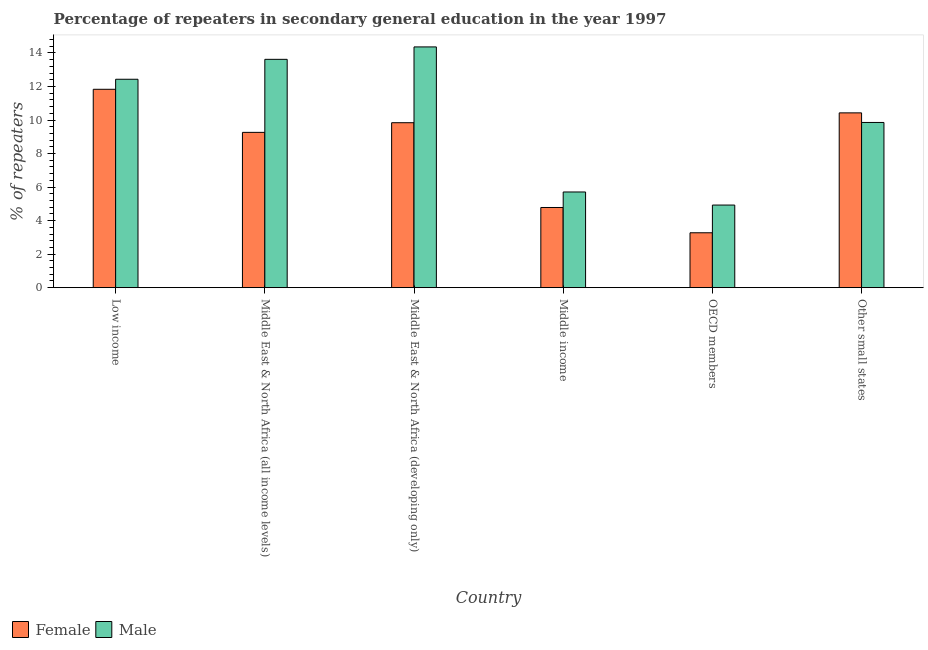How many different coloured bars are there?
Offer a terse response. 2. How many groups of bars are there?
Keep it short and to the point. 6. Are the number of bars on each tick of the X-axis equal?
Ensure brevity in your answer.  Yes. In how many cases, is the number of bars for a given country not equal to the number of legend labels?
Offer a very short reply. 0. What is the percentage of female repeaters in OECD members?
Make the answer very short. 3.27. Across all countries, what is the maximum percentage of female repeaters?
Give a very brief answer. 11.83. Across all countries, what is the minimum percentage of male repeaters?
Give a very brief answer. 4.93. In which country was the percentage of female repeaters maximum?
Offer a very short reply. Low income. In which country was the percentage of male repeaters minimum?
Ensure brevity in your answer.  OECD members. What is the total percentage of male repeaters in the graph?
Keep it short and to the point. 60.9. What is the difference between the percentage of female repeaters in Low income and that in Middle East & North Africa (developing only)?
Your answer should be very brief. 1.99. What is the difference between the percentage of female repeaters in OECD members and the percentage of male repeaters in Middle East & North Africa (all income levels)?
Give a very brief answer. -10.35. What is the average percentage of male repeaters per country?
Your answer should be very brief. 10.15. What is the difference between the percentage of female repeaters and percentage of male repeaters in Middle East & North Africa (all income levels)?
Ensure brevity in your answer.  -4.36. What is the ratio of the percentage of female repeaters in Middle East & North Africa (all income levels) to that in Middle East & North Africa (developing only)?
Offer a very short reply. 0.94. What is the difference between the highest and the second highest percentage of female repeaters?
Your answer should be compact. 1.41. What is the difference between the highest and the lowest percentage of male repeaters?
Your response must be concise. 9.43. Is the sum of the percentage of male repeaters in Middle East & North Africa (developing only) and OECD members greater than the maximum percentage of female repeaters across all countries?
Your response must be concise. Yes. What does the 1st bar from the right in Other small states represents?
Your response must be concise. Male. How many bars are there?
Your response must be concise. 12. Are all the bars in the graph horizontal?
Make the answer very short. No. How many countries are there in the graph?
Offer a terse response. 6. What is the difference between two consecutive major ticks on the Y-axis?
Give a very brief answer. 2. Does the graph contain grids?
Provide a succinct answer. No. How many legend labels are there?
Provide a succinct answer. 2. What is the title of the graph?
Keep it short and to the point. Percentage of repeaters in secondary general education in the year 1997. Does "Subsidies" appear as one of the legend labels in the graph?
Your answer should be very brief. No. What is the label or title of the Y-axis?
Provide a succinct answer. % of repeaters. What is the % of repeaters of Female in Low income?
Provide a succinct answer. 11.83. What is the % of repeaters of Male in Low income?
Offer a very short reply. 12.43. What is the % of repeaters of Female in Middle East & North Africa (all income levels)?
Your answer should be compact. 9.26. What is the % of repeaters of Male in Middle East & North Africa (all income levels)?
Your answer should be compact. 13.62. What is the % of repeaters in Female in Middle East & North Africa (developing only)?
Offer a terse response. 9.84. What is the % of repeaters of Male in Middle East & North Africa (developing only)?
Give a very brief answer. 14.36. What is the % of repeaters in Female in Middle income?
Provide a succinct answer. 4.78. What is the % of repeaters of Male in Middle income?
Provide a short and direct response. 5.71. What is the % of repeaters in Female in OECD members?
Offer a terse response. 3.27. What is the % of repeaters in Male in OECD members?
Provide a succinct answer. 4.93. What is the % of repeaters of Female in Other small states?
Your response must be concise. 10.43. What is the % of repeaters in Male in Other small states?
Your response must be concise. 9.85. Across all countries, what is the maximum % of repeaters in Female?
Your response must be concise. 11.83. Across all countries, what is the maximum % of repeaters in Male?
Offer a very short reply. 14.36. Across all countries, what is the minimum % of repeaters of Female?
Offer a very short reply. 3.27. Across all countries, what is the minimum % of repeaters in Male?
Your response must be concise. 4.93. What is the total % of repeaters of Female in the graph?
Your answer should be compact. 49.42. What is the total % of repeaters of Male in the graph?
Keep it short and to the point. 60.9. What is the difference between the % of repeaters in Female in Low income and that in Middle East & North Africa (all income levels)?
Offer a terse response. 2.57. What is the difference between the % of repeaters of Male in Low income and that in Middle East & North Africa (all income levels)?
Offer a terse response. -1.19. What is the difference between the % of repeaters in Female in Low income and that in Middle East & North Africa (developing only)?
Offer a very short reply. 1.99. What is the difference between the % of repeaters in Male in Low income and that in Middle East & North Africa (developing only)?
Your answer should be very brief. -1.93. What is the difference between the % of repeaters of Female in Low income and that in Middle income?
Your response must be concise. 7.05. What is the difference between the % of repeaters of Male in Low income and that in Middle income?
Ensure brevity in your answer.  6.72. What is the difference between the % of repeaters in Female in Low income and that in OECD members?
Your response must be concise. 8.56. What is the difference between the % of repeaters of Male in Low income and that in OECD members?
Your response must be concise. 7.5. What is the difference between the % of repeaters of Female in Low income and that in Other small states?
Keep it short and to the point. 1.41. What is the difference between the % of repeaters in Male in Low income and that in Other small states?
Ensure brevity in your answer.  2.58. What is the difference between the % of repeaters in Female in Middle East & North Africa (all income levels) and that in Middle East & North Africa (developing only)?
Provide a succinct answer. -0.58. What is the difference between the % of repeaters of Male in Middle East & North Africa (all income levels) and that in Middle East & North Africa (developing only)?
Ensure brevity in your answer.  -0.74. What is the difference between the % of repeaters in Female in Middle East & North Africa (all income levels) and that in Middle income?
Offer a very short reply. 4.48. What is the difference between the % of repeaters of Male in Middle East & North Africa (all income levels) and that in Middle income?
Ensure brevity in your answer.  7.91. What is the difference between the % of repeaters in Female in Middle East & North Africa (all income levels) and that in OECD members?
Your answer should be compact. 5.99. What is the difference between the % of repeaters of Male in Middle East & North Africa (all income levels) and that in OECD members?
Offer a terse response. 8.69. What is the difference between the % of repeaters in Female in Middle East & North Africa (all income levels) and that in Other small states?
Your answer should be very brief. -1.16. What is the difference between the % of repeaters in Male in Middle East & North Africa (all income levels) and that in Other small states?
Make the answer very short. 3.77. What is the difference between the % of repeaters of Female in Middle East & North Africa (developing only) and that in Middle income?
Provide a succinct answer. 5.06. What is the difference between the % of repeaters in Male in Middle East & North Africa (developing only) and that in Middle income?
Ensure brevity in your answer.  8.65. What is the difference between the % of repeaters in Female in Middle East & North Africa (developing only) and that in OECD members?
Keep it short and to the point. 6.56. What is the difference between the % of repeaters in Male in Middle East & North Africa (developing only) and that in OECD members?
Your answer should be very brief. 9.43. What is the difference between the % of repeaters in Female in Middle East & North Africa (developing only) and that in Other small states?
Make the answer very short. -0.59. What is the difference between the % of repeaters in Male in Middle East & North Africa (developing only) and that in Other small states?
Offer a very short reply. 4.51. What is the difference between the % of repeaters in Female in Middle income and that in OECD members?
Your answer should be very brief. 1.51. What is the difference between the % of repeaters of Male in Middle income and that in OECD members?
Ensure brevity in your answer.  0.78. What is the difference between the % of repeaters in Female in Middle income and that in Other small states?
Provide a short and direct response. -5.64. What is the difference between the % of repeaters of Male in Middle income and that in Other small states?
Ensure brevity in your answer.  -4.15. What is the difference between the % of repeaters of Female in OECD members and that in Other small states?
Give a very brief answer. -7.15. What is the difference between the % of repeaters in Male in OECD members and that in Other small states?
Make the answer very short. -4.93. What is the difference between the % of repeaters in Female in Low income and the % of repeaters in Male in Middle East & North Africa (all income levels)?
Your answer should be compact. -1.79. What is the difference between the % of repeaters in Female in Low income and the % of repeaters in Male in Middle East & North Africa (developing only)?
Your answer should be very brief. -2.53. What is the difference between the % of repeaters in Female in Low income and the % of repeaters in Male in Middle income?
Keep it short and to the point. 6.12. What is the difference between the % of repeaters in Female in Low income and the % of repeaters in Male in OECD members?
Your response must be concise. 6.9. What is the difference between the % of repeaters in Female in Low income and the % of repeaters in Male in Other small states?
Provide a succinct answer. 1.98. What is the difference between the % of repeaters in Female in Middle East & North Africa (all income levels) and the % of repeaters in Male in Middle East & North Africa (developing only)?
Offer a very short reply. -5.1. What is the difference between the % of repeaters of Female in Middle East & North Africa (all income levels) and the % of repeaters of Male in Middle income?
Ensure brevity in your answer.  3.56. What is the difference between the % of repeaters in Female in Middle East & North Africa (all income levels) and the % of repeaters in Male in OECD members?
Make the answer very short. 4.34. What is the difference between the % of repeaters of Female in Middle East & North Africa (all income levels) and the % of repeaters of Male in Other small states?
Give a very brief answer. -0.59. What is the difference between the % of repeaters of Female in Middle East & North Africa (developing only) and the % of repeaters of Male in Middle income?
Ensure brevity in your answer.  4.13. What is the difference between the % of repeaters in Female in Middle East & North Africa (developing only) and the % of repeaters in Male in OECD members?
Provide a short and direct response. 4.91. What is the difference between the % of repeaters in Female in Middle East & North Africa (developing only) and the % of repeaters in Male in Other small states?
Offer a terse response. -0.02. What is the difference between the % of repeaters of Female in Middle income and the % of repeaters of Male in OECD members?
Keep it short and to the point. -0.14. What is the difference between the % of repeaters in Female in Middle income and the % of repeaters in Male in Other small states?
Give a very brief answer. -5.07. What is the difference between the % of repeaters in Female in OECD members and the % of repeaters in Male in Other small states?
Provide a succinct answer. -6.58. What is the average % of repeaters of Female per country?
Offer a terse response. 8.24. What is the average % of repeaters in Male per country?
Provide a short and direct response. 10.15. What is the difference between the % of repeaters of Female and % of repeaters of Male in Low income?
Keep it short and to the point. -0.6. What is the difference between the % of repeaters in Female and % of repeaters in Male in Middle East & North Africa (all income levels)?
Keep it short and to the point. -4.36. What is the difference between the % of repeaters of Female and % of repeaters of Male in Middle East & North Africa (developing only)?
Provide a succinct answer. -4.52. What is the difference between the % of repeaters of Female and % of repeaters of Male in Middle income?
Your answer should be compact. -0.92. What is the difference between the % of repeaters in Female and % of repeaters in Male in OECD members?
Provide a short and direct response. -1.65. What is the difference between the % of repeaters of Female and % of repeaters of Male in Other small states?
Your answer should be very brief. 0.57. What is the ratio of the % of repeaters in Female in Low income to that in Middle East & North Africa (all income levels)?
Keep it short and to the point. 1.28. What is the ratio of the % of repeaters of Male in Low income to that in Middle East & North Africa (all income levels)?
Provide a succinct answer. 0.91. What is the ratio of the % of repeaters of Female in Low income to that in Middle East & North Africa (developing only)?
Make the answer very short. 1.2. What is the ratio of the % of repeaters of Male in Low income to that in Middle East & North Africa (developing only)?
Give a very brief answer. 0.87. What is the ratio of the % of repeaters in Female in Low income to that in Middle income?
Offer a very short reply. 2.47. What is the ratio of the % of repeaters in Male in Low income to that in Middle income?
Make the answer very short. 2.18. What is the ratio of the % of repeaters in Female in Low income to that in OECD members?
Make the answer very short. 3.61. What is the ratio of the % of repeaters in Male in Low income to that in OECD members?
Your answer should be compact. 2.52. What is the ratio of the % of repeaters of Female in Low income to that in Other small states?
Offer a very short reply. 1.13. What is the ratio of the % of repeaters in Male in Low income to that in Other small states?
Your answer should be compact. 1.26. What is the ratio of the % of repeaters in Female in Middle East & North Africa (all income levels) to that in Middle East & North Africa (developing only)?
Offer a very short reply. 0.94. What is the ratio of the % of repeaters of Male in Middle East & North Africa (all income levels) to that in Middle East & North Africa (developing only)?
Keep it short and to the point. 0.95. What is the ratio of the % of repeaters of Female in Middle East & North Africa (all income levels) to that in Middle income?
Offer a very short reply. 1.94. What is the ratio of the % of repeaters in Male in Middle East & North Africa (all income levels) to that in Middle income?
Provide a succinct answer. 2.39. What is the ratio of the % of repeaters in Female in Middle East & North Africa (all income levels) to that in OECD members?
Your answer should be compact. 2.83. What is the ratio of the % of repeaters in Male in Middle East & North Africa (all income levels) to that in OECD members?
Keep it short and to the point. 2.76. What is the ratio of the % of repeaters in Female in Middle East & North Africa (all income levels) to that in Other small states?
Offer a terse response. 0.89. What is the ratio of the % of repeaters in Male in Middle East & North Africa (all income levels) to that in Other small states?
Provide a short and direct response. 1.38. What is the ratio of the % of repeaters of Female in Middle East & North Africa (developing only) to that in Middle income?
Make the answer very short. 2.06. What is the ratio of the % of repeaters in Male in Middle East & North Africa (developing only) to that in Middle income?
Provide a short and direct response. 2.52. What is the ratio of the % of repeaters of Female in Middle East & North Africa (developing only) to that in OECD members?
Your answer should be compact. 3. What is the ratio of the % of repeaters in Male in Middle East & North Africa (developing only) to that in OECD members?
Offer a very short reply. 2.91. What is the ratio of the % of repeaters of Female in Middle East & North Africa (developing only) to that in Other small states?
Give a very brief answer. 0.94. What is the ratio of the % of repeaters of Male in Middle East & North Africa (developing only) to that in Other small states?
Give a very brief answer. 1.46. What is the ratio of the % of repeaters in Female in Middle income to that in OECD members?
Offer a terse response. 1.46. What is the ratio of the % of repeaters of Male in Middle income to that in OECD members?
Make the answer very short. 1.16. What is the ratio of the % of repeaters in Female in Middle income to that in Other small states?
Offer a terse response. 0.46. What is the ratio of the % of repeaters of Male in Middle income to that in Other small states?
Offer a terse response. 0.58. What is the ratio of the % of repeaters in Female in OECD members to that in Other small states?
Offer a very short reply. 0.31. What is the difference between the highest and the second highest % of repeaters in Female?
Your response must be concise. 1.41. What is the difference between the highest and the second highest % of repeaters of Male?
Ensure brevity in your answer.  0.74. What is the difference between the highest and the lowest % of repeaters in Female?
Make the answer very short. 8.56. What is the difference between the highest and the lowest % of repeaters of Male?
Your answer should be very brief. 9.43. 